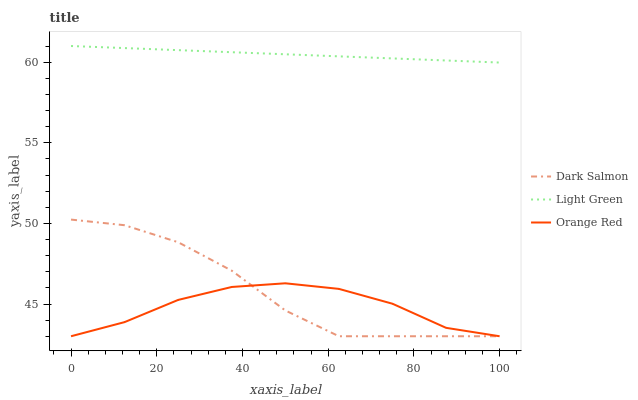Does Orange Red have the minimum area under the curve?
Answer yes or no. Yes. Does Light Green have the maximum area under the curve?
Answer yes or no. Yes. Does Light Green have the minimum area under the curve?
Answer yes or no. No. Does Orange Red have the maximum area under the curve?
Answer yes or no. No. Is Light Green the smoothest?
Answer yes or no. Yes. Is Dark Salmon the roughest?
Answer yes or no. Yes. Is Orange Red the smoothest?
Answer yes or no. No. Is Orange Red the roughest?
Answer yes or no. No. Does Dark Salmon have the lowest value?
Answer yes or no. Yes. Does Light Green have the lowest value?
Answer yes or no. No. Does Light Green have the highest value?
Answer yes or no. Yes. Does Orange Red have the highest value?
Answer yes or no. No. Is Orange Red less than Light Green?
Answer yes or no. Yes. Is Light Green greater than Orange Red?
Answer yes or no. Yes. Does Orange Red intersect Dark Salmon?
Answer yes or no. Yes. Is Orange Red less than Dark Salmon?
Answer yes or no. No. Is Orange Red greater than Dark Salmon?
Answer yes or no. No. Does Orange Red intersect Light Green?
Answer yes or no. No. 